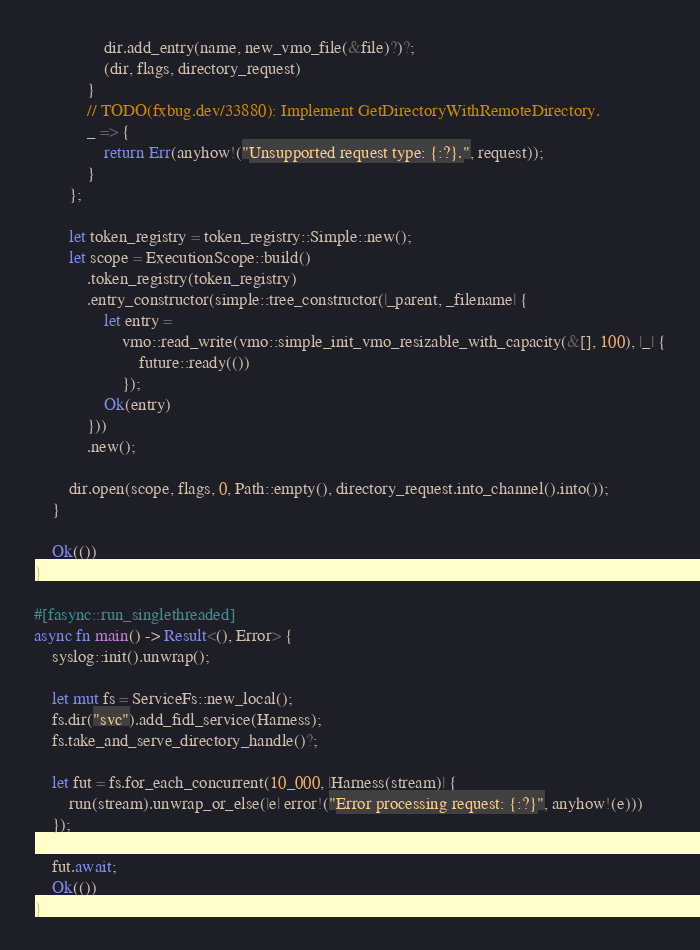<code> <loc_0><loc_0><loc_500><loc_500><_Rust_>                dir.add_entry(name, new_vmo_file(&file)?)?;
                (dir, flags, directory_request)
            }
            // TODO(fxbug.dev/33880): Implement GetDirectoryWithRemoteDirectory.
            _ => {
                return Err(anyhow!("Unsupported request type: {:?}.", request));
            }
        };

        let token_registry = token_registry::Simple::new();
        let scope = ExecutionScope::build()
            .token_registry(token_registry)
            .entry_constructor(simple::tree_constructor(|_parent, _filename| {
                let entry =
                    vmo::read_write(vmo::simple_init_vmo_resizable_with_capacity(&[], 100), |_| {
                        future::ready(())
                    });
                Ok(entry)
            }))
            .new();

        dir.open(scope, flags, 0, Path::empty(), directory_request.into_channel().into());
    }

    Ok(())
}

#[fasync::run_singlethreaded]
async fn main() -> Result<(), Error> {
    syslog::init().unwrap();

    let mut fs = ServiceFs::new_local();
    fs.dir("svc").add_fidl_service(Harness);
    fs.take_and_serve_directory_handle()?;

    let fut = fs.for_each_concurrent(10_000, |Harness(stream)| {
        run(stream).unwrap_or_else(|e| error!("Error processing request: {:?}", anyhow!(e)))
    });

    fut.await;
    Ok(())
}
</code> 